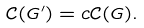<formula> <loc_0><loc_0><loc_500><loc_500>\mathcal { C } ( G ^ { \prime } ) = c \mathcal { C } ( G ) .</formula> 